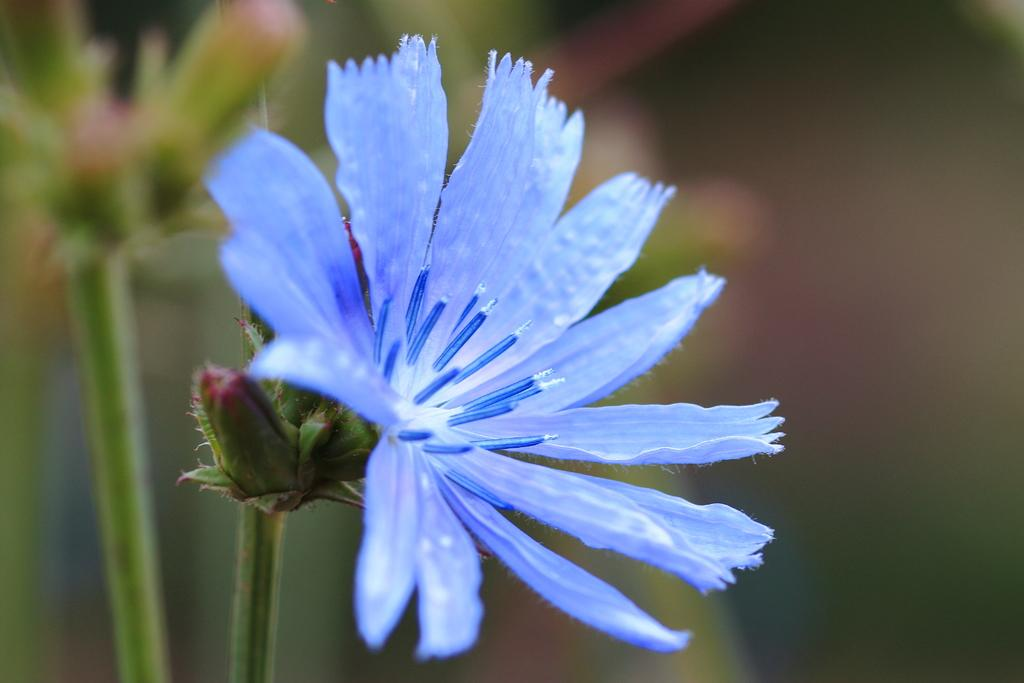What is present in the picture? There is a plant in the picture. Can you describe the plant's structure? The plant has a stem. What additional feature can be seen on the plant? The plant has a flower. What type of decision can be seen being made by the vegetable in the image? There is no vegetable present in the image, and therefore no decision-making can be observed. 